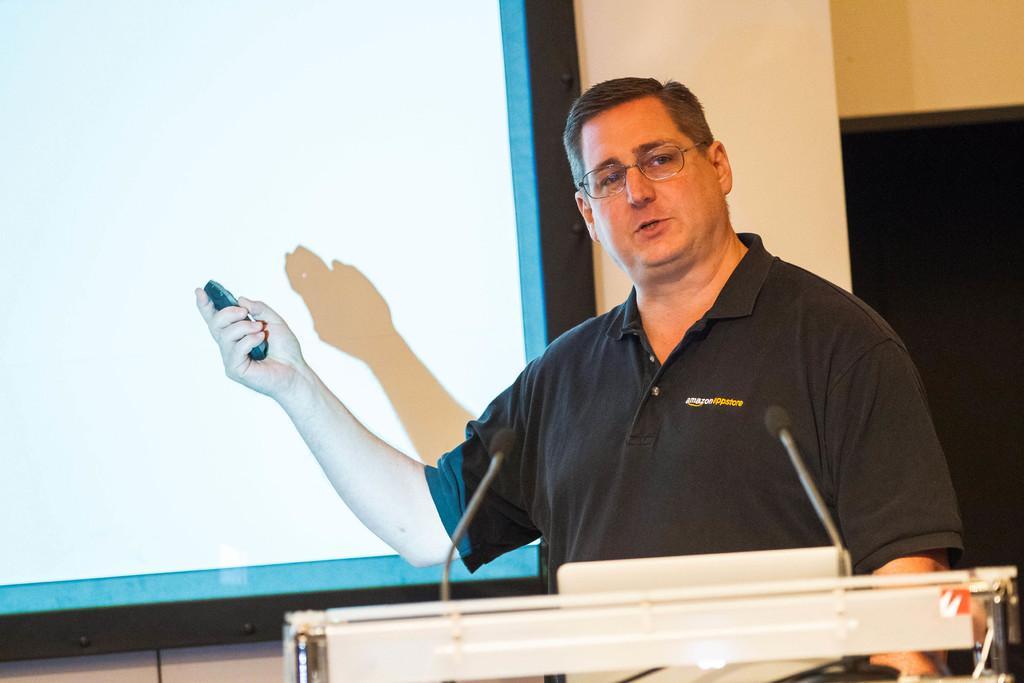Could you give a brief overview of what you see in this image? In this picture I can see a man standing at a podium and he is holding a remote in his hand. I can see a projector screen, couple of microphones and it looks like a laptop on the podium. 